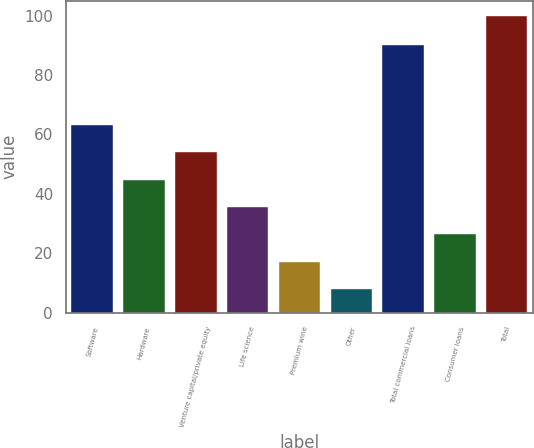Convert chart. <chart><loc_0><loc_0><loc_500><loc_500><bar_chart><fcel>Software<fcel>Hardware<fcel>Venture capital/private equity<fcel>Life science<fcel>Premium wine<fcel>Other<fcel>Total commercial loans<fcel>Consumer loans<fcel>Total<nl><fcel>63.16<fcel>44.74<fcel>53.95<fcel>35.53<fcel>17.11<fcel>7.9<fcel>90<fcel>26.32<fcel>100<nl></chart> 